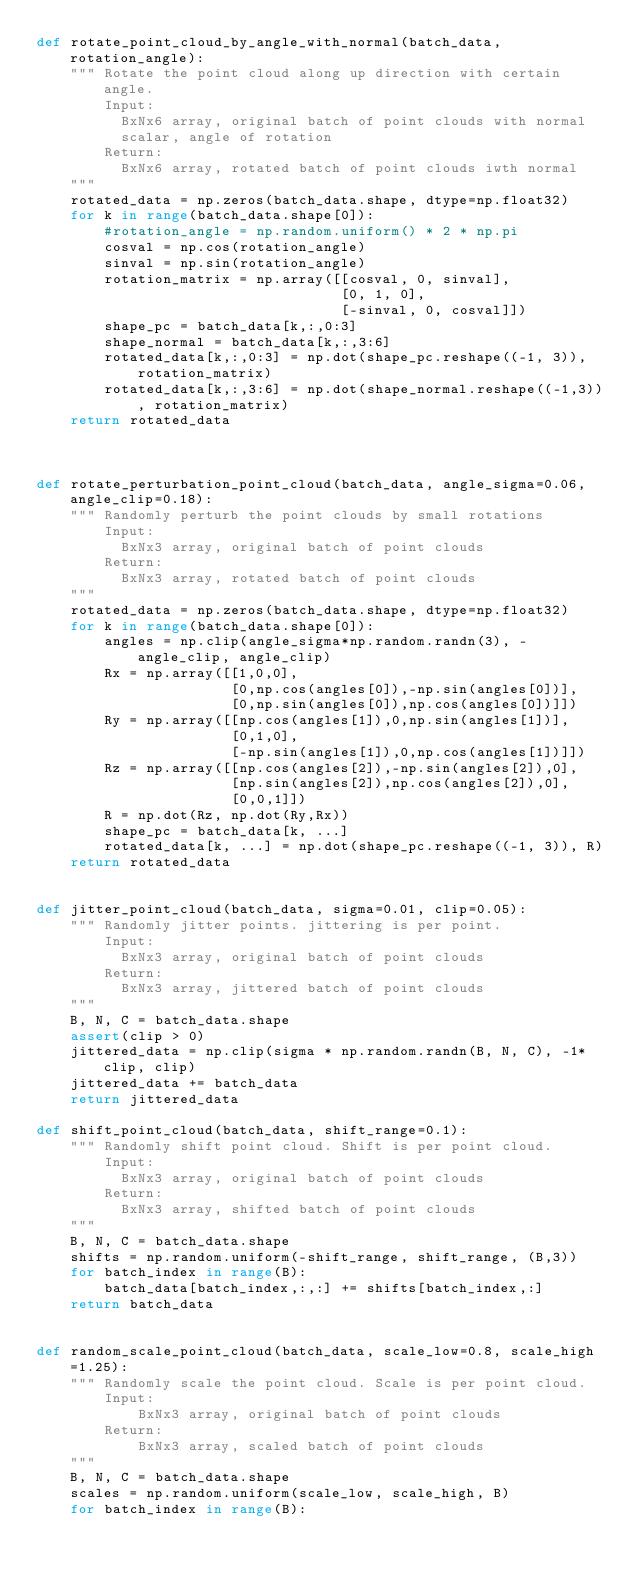<code> <loc_0><loc_0><loc_500><loc_500><_Python_>def rotate_point_cloud_by_angle_with_normal(batch_data, rotation_angle):
    """ Rotate the point cloud along up direction with certain angle.
        Input:
          BxNx6 array, original batch of point clouds with normal
          scalar, angle of rotation
        Return:
          BxNx6 array, rotated batch of point clouds iwth normal
    """
    rotated_data = np.zeros(batch_data.shape, dtype=np.float32)
    for k in range(batch_data.shape[0]):
        #rotation_angle = np.random.uniform() * 2 * np.pi
        cosval = np.cos(rotation_angle)
        sinval = np.sin(rotation_angle)
        rotation_matrix = np.array([[cosval, 0, sinval],
                                    [0, 1, 0],
                                    [-sinval, 0, cosval]])
        shape_pc = batch_data[k,:,0:3]
        shape_normal = batch_data[k,:,3:6]
        rotated_data[k,:,0:3] = np.dot(shape_pc.reshape((-1, 3)), rotation_matrix)
        rotated_data[k,:,3:6] = np.dot(shape_normal.reshape((-1,3)), rotation_matrix)
    return rotated_data



def rotate_perturbation_point_cloud(batch_data, angle_sigma=0.06, angle_clip=0.18):
    """ Randomly perturb the point clouds by small rotations
        Input:
          BxNx3 array, original batch of point clouds
        Return:
          BxNx3 array, rotated batch of point clouds
    """
    rotated_data = np.zeros(batch_data.shape, dtype=np.float32)
    for k in range(batch_data.shape[0]):
        angles = np.clip(angle_sigma*np.random.randn(3), -angle_clip, angle_clip)
        Rx = np.array([[1,0,0],
                       [0,np.cos(angles[0]),-np.sin(angles[0])],
                       [0,np.sin(angles[0]),np.cos(angles[0])]])
        Ry = np.array([[np.cos(angles[1]),0,np.sin(angles[1])],
                       [0,1,0],
                       [-np.sin(angles[1]),0,np.cos(angles[1])]])
        Rz = np.array([[np.cos(angles[2]),-np.sin(angles[2]),0],
                       [np.sin(angles[2]),np.cos(angles[2]),0],
                       [0,0,1]])
        R = np.dot(Rz, np.dot(Ry,Rx))
        shape_pc = batch_data[k, ...]
        rotated_data[k, ...] = np.dot(shape_pc.reshape((-1, 3)), R)
    return rotated_data


def jitter_point_cloud(batch_data, sigma=0.01, clip=0.05):
    """ Randomly jitter points. jittering is per point.
        Input:
          BxNx3 array, original batch of point clouds
        Return:
          BxNx3 array, jittered batch of point clouds
    """
    B, N, C = batch_data.shape
    assert(clip > 0)
    jittered_data = np.clip(sigma * np.random.randn(B, N, C), -1*clip, clip)
    jittered_data += batch_data
    return jittered_data

def shift_point_cloud(batch_data, shift_range=0.1):
    """ Randomly shift point cloud. Shift is per point cloud.
        Input:
          BxNx3 array, original batch of point clouds
        Return:
          BxNx3 array, shifted batch of point clouds
    """
    B, N, C = batch_data.shape
    shifts = np.random.uniform(-shift_range, shift_range, (B,3))
    for batch_index in range(B):
        batch_data[batch_index,:,:] += shifts[batch_index,:]
    return batch_data


def random_scale_point_cloud(batch_data, scale_low=0.8, scale_high=1.25):
    """ Randomly scale the point cloud. Scale is per point cloud.
        Input:
            BxNx3 array, original batch of point clouds
        Return:
            BxNx3 array, scaled batch of point clouds
    """
    B, N, C = batch_data.shape
    scales = np.random.uniform(scale_low, scale_high, B)
    for batch_index in range(B):</code> 